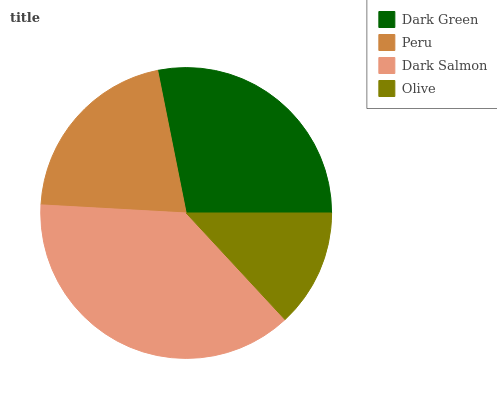Is Olive the minimum?
Answer yes or no. Yes. Is Dark Salmon the maximum?
Answer yes or no. Yes. Is Peru the minimum?
Answer yes or no. No. Is Peru the maximum?
Answer yes or no. No. Is Dark Green greater than Peru?
Answer yes or no. Yes. Is Peru less than Dark Green?
Answer yes or no. Yes. Is Peru greater than Dark Green?
Answer yes or no. No. Is Dark Green less than Peru?
Answer yes or no. No. Is Dark Green the high median?
Answer yes or no. Yes. Is Peru the low median?
Answer yes or no. Yes. Is Peru the high median?
Answer yes or no. No. Is Olive the low median?
Answer yes or no. No. 